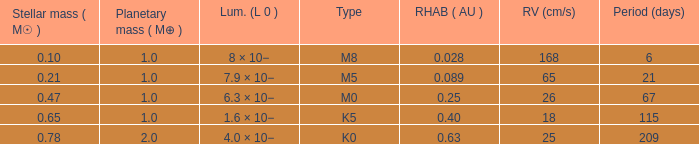Could you parse the entire table as a dict? {'header': ['Stellar mass ( M☉ )', 'Planetary mass ( M⊕ )', 'Lum. (L 0 )', 'Type', 'RHAB ( AU )', 'RV (cm/s)', 'Period (days)'], 'rows': [['0.10', '1.0', '8 × 10−', 'M8', '0.028', '168', '6'], ['0.21', '1.0', '7.9 × 10−', 'M5', '0.089', '65', '21'], ['0.47', '1.0', '6.3 × 10−', 'M0', '0.25', '26', '67'], ['0.65', '1.0', '1.6 × 10−', 'K5', '0.40', '18', '115'], ['0.78', '2.0', '4.0 × 10−', 'K0', '0.63', '25', '209']]} What is the total mass of stars classified as type m0? 0.47. 